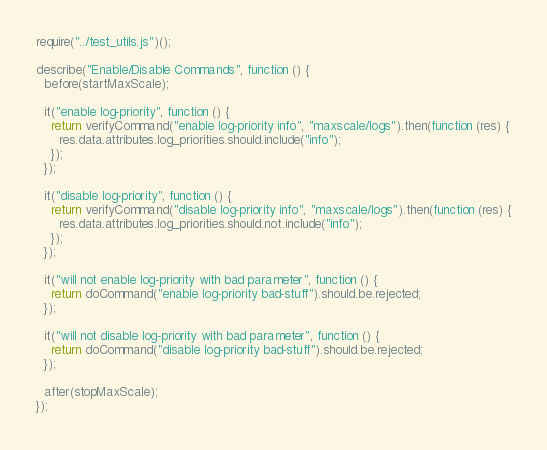<code> <loc_0><loc_0><loc_500><loc_500><_JavaScript_>require("../test_utils.js")();

describe("Enable/Disable Commands", function () {
  before(startMaxScale);

  it("enable log-priority", function () {
    return verifyCommand("enable log-priority info", "maxscale/logs").then(function (res) {
      res.data.attributes.log_priorities.should.include("info");
    });
  });

  it("disable log-priority", function () {
    return verifyCommand("disable log-priority info", "maxscale/logs").then(function (res) {
      res.data.attributes.log_priorities.should.not.include("info");
    });
  });

  it("will not enable log-priority with bad parameter", function () {
    return doCommand("enable log-priority bad-stuff").should.be.rejected;
  });

  it("will not disable log-priority with bad parameter", function () {
    return doCommand("disable log-priority bad-stuff").should.be.rejected;
  });

  after(stopMaxScale);
});
</code> 